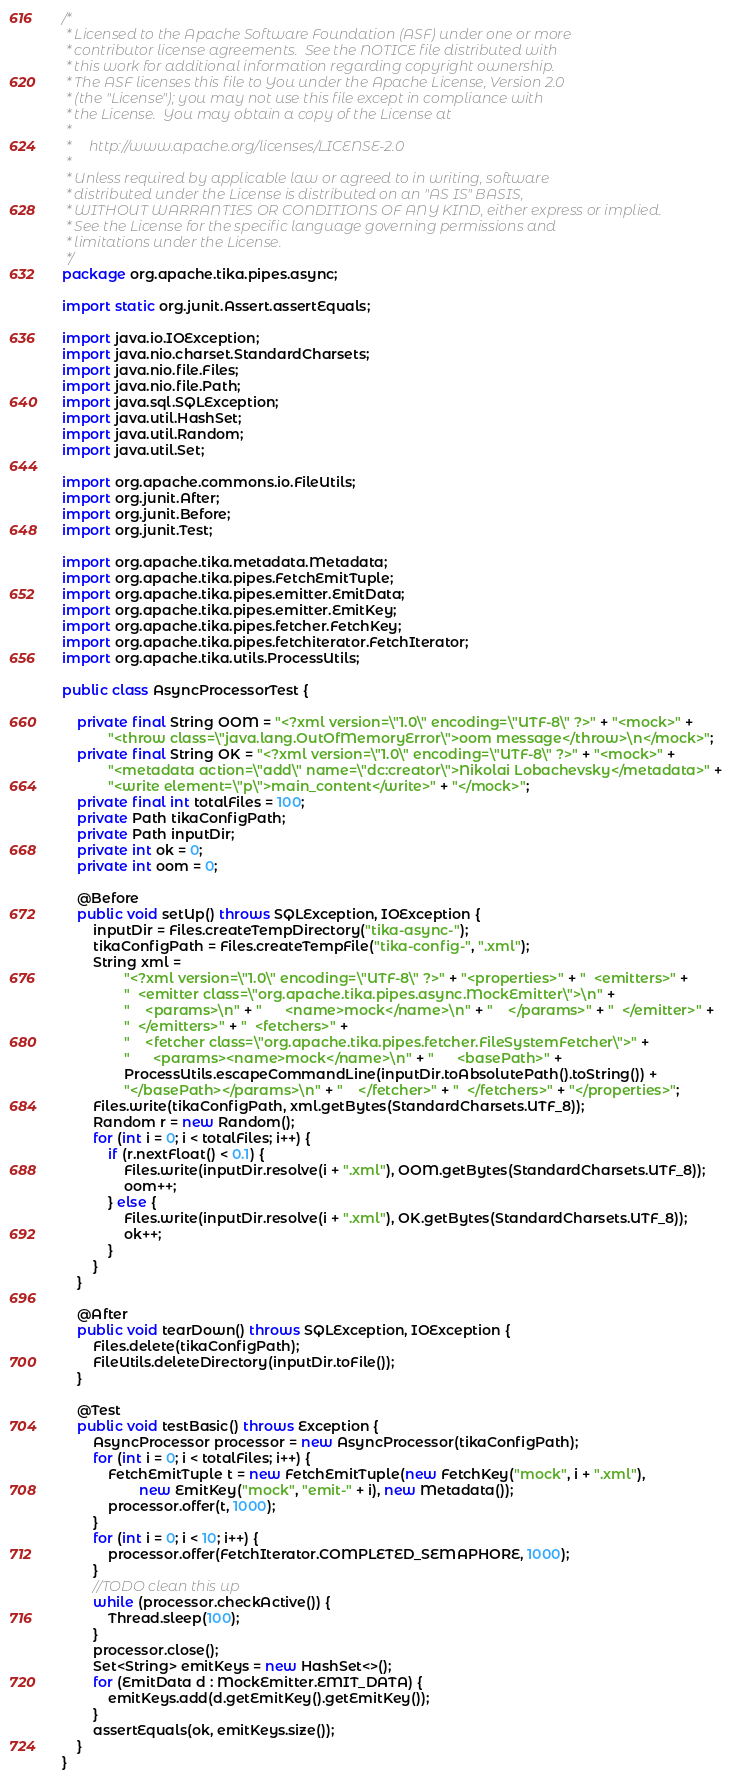<code> <loc_0><loc_0><loc_500><loc_500><_Java_>/*
 * Licensed to the Apache Software Foundation (ASF) under one or more
 * contributor license agreements.  See the NOTICE file distributed with
 * this work for additional information regarding copyright ownership.
 * The ASF licenses this file to You under the Apache License, Version 2.0
 * (the "License"); you may not use this file except in compliance with
 * the License.  You may obtain a copy of the License at
 *
 *     http://www.apache.org/licenses/LICENSE-2.0
 *
 * Unless required by applicable law or agreed to in writing, software
 * distributed under the License is distributed on an "AS IS" BASIS,
 * WITHOUT WARRANTIES OR CONDITIONS OF ANY KIND, either express or implied.
 * See the License for the specific language governing permissions and
 * limitations under the License.
 */
package org.apache.tika.pipes.async;

import static org.junit.Assert.assertEquals;

import java.io.IOException;
import java.nio.charset.StandardCharsets;
import java.nio.file.Files;
import java.nio.file.Path;
import java.sql.SQLException;
import java.util.HashSet;
import java.util.Random;
import java.util.Set;

import org.apache.commons.io.FileUtils;
import org.junit.After;
import org.junit.Before;
import org.junit.Test;

import org.apache.tika.metadata.Metadata;
import org.apache.tika.pipes.FetchEmitTuple;
import org.apache.tika.pipes.emitter.EmitData;
import org.apache.tika.pipes.emitter.EmitKey;
import org.apache.tika.pipes.fetcher.FetchKey;
import org.apache.tika.pipes.fetchiterator.FetchIterator;
import org.apache.tika.utils.ProcessUtils;

public class AsyncProcessorTest {

    private final String OOM = "<?xml version=\"1.0\" encoding=\"UTF-8\" ?>" + "<mock>" +
            "<throw class=\"java.lang.OutOfMemoryError\">oom message</throw>\n</mock>";
    private final String OK = "<?xml version=\"1.0\" encoding=\"UTF-8\" ?>" + "<mock>" +
            "<metadata action=\"add\" name=\"dc:creator\">Nikolai Lobachevsky</metadata>" +
            "<write element=\"p\">main_content</write>" + "</mock>";
    private final int totalFiles = 100;
    private Path tikaConfigPath;
    private Path inputDir;
    private int ok = 0;
    private int oom = 0;

    @Before
    public void setUp() throws SQLException, IOException {
        inputDir = Files.createTempDirectory("tika-async-");
        tikaConfigPath = Files.createTempFile("tika-config-", ".xml");
        String xml =
                "<?xml version=\"1.0\" encoding=\"UTF-8\" ?>" + "<properties>" + "  <emitters>" +
                "  <emitter class=\"org.apache.tika.pipes.async.MockEmitter\">\n" +
                "    <params>\n" + "      <name>mock</name>\n" + "    </params>" + "  </emitter>" +
                "  </emitters>" + "  <fetchers>" +
                "    <fetcher class=\"org.apache.tika.pipes.fetcher.FileSystemFetcher\">" +
                "      <params><name>mock</name>\n" + "      <basePath>" +
                ProcessUtils.escapeCommandLine(inputDir.toAbsolutePath().toString()) +
                "</basePath></params>\n" + "    </fetcher>" + "  </fetchers>" + "</properties>";
        Files.write(tikaConfigPath, xml.getBytes(StandardCharsets.UTF_8));
        Random r = new Random();
        for (int i = 0; i < totalFiles; i++) {
            if (r.nextFloat() < 0.1) {
                Files.write(inputDir.resolve(i + ".xml"), OOM.getBytes(StandardCharsets.UTF_8));
                oom++;
            } else {
                Files.write(inputDir.resolve(i + ".xml"), OK.getBytes(StandardCharsets.UTF_8));
                ok++;
            }
        }
    }

    @After
    public void tearDown() throws SQLException, IOException {
        Files.delete(tikaConfigPath);
        FileUtils.deleteDirectory(inputDir.toFile());
    }

    @Test
    public void testBasic() throws Exception {
        AsyncProcessor processor = new AsyncProcessor(tikaConfigPath);
        for (int i = 0; i < totalFiles; i++) {
            FetchEmitTuple t = new FetchEmitTuple(new FetchKey("mock", i + ".xml"),
                    new EmitKey("mock", "emit-" + i), new Metadata());
            processor.offer(t, 1000);
        }
        for (int i = 0; i < 10; i++) {
            processor.offer(FetchIterator.COMPLETED_SEMAPHORE, 1000);
        }
        //TODO clean this up
        while (processor.checkActive()) {
            Thread.sleep(100);
        }
        processor.close();
        Set<String> emitKeys = new HashSet<>();
        for (EmitData d : MockEmitter.EMIT_DATA) {
            emitKeys.add(d.getEmitKey().getEmitKey());
        }
        assertEquals(ok, emitKeys.size());
    }
}
</code> 